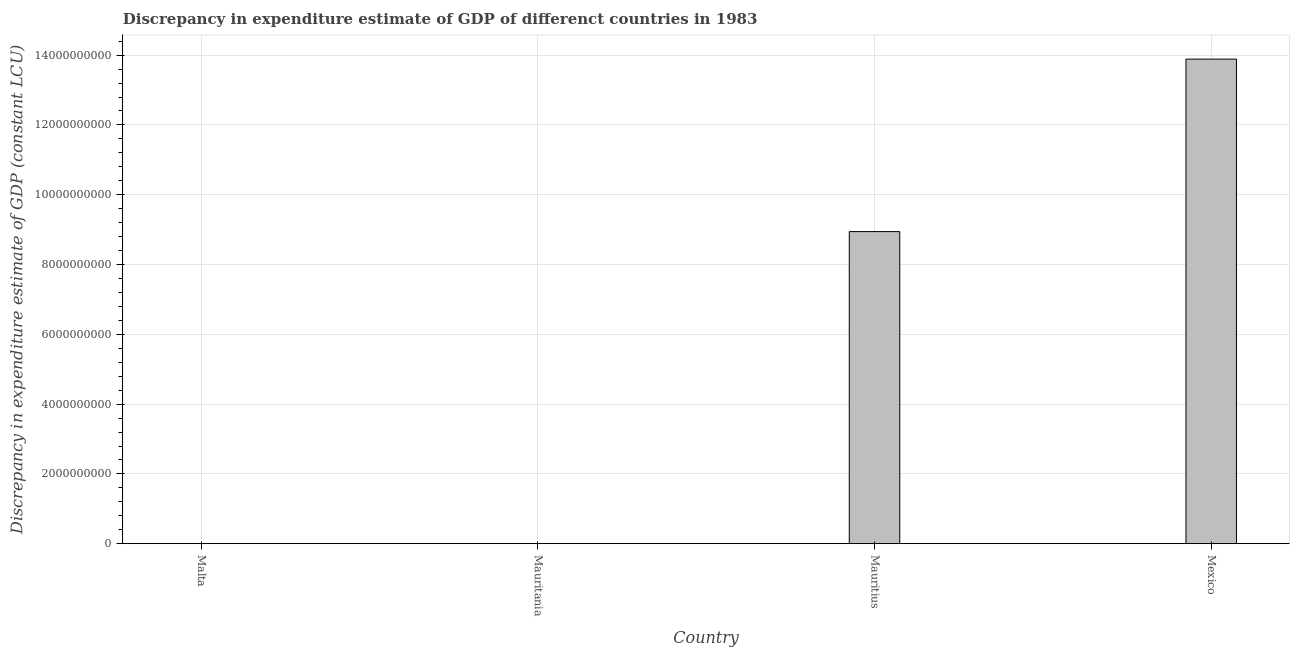Does the graph contain grids?
Provide a short and direct response. Yes. What is the title of the graph?
Give a very brief answer. Discrepancy in expenditure estimate of GDP of differenct countries in 1983. What is the label or title of the X-axis?
Offer a very short reply. Country. What is the label or title of the Y-axis?
Keep it short and to the point. Discrepancy in expenditure estimate of GDP (constant LCU). What is the discrepancy in expenditure estimate of gdp in Mexico?
Your answer should be compact. 1.39e+1. Across all countries, what is the maximum discrepancy in expenditure estimate of gdp?
Your answer should be very brief. 1.39e+1. Across all countries, what is the minimum discrepancy in expenditure estimate of gdp?
Offer a very short reply. 0. What is the sum of the discrepancy in expenditure estimate of gdp?
Provide a succinct answer. 2.28e+1. What is the average discrepancy in expenditure estimate of gdp per country?
Provide a short and direct response. 5.71e+09. What is the median discrepancy in expenditure estimate of gdp?
Provide a short and direct response. 4.47e+09. In how many countries, is the discrepancy in expenditure estimate of gdp greater than 1200000000 LCU?
Offer a very short reply. 2. What is the ratio of the discrepancy in expenditure estimate of gdp in Mauritius to that in Mexico?
Offer a terse response. 0.64. What is the difference between the highest and the lowest discrepancy in expenditure estimate of gdp?
Offer a terse response. 1.39e+1. In how many countries, is the discrepancy in expenditure estimate of gdp greater than the average discrepancy in expenditure estimate of gdp taken over all countries?
Offer a very short reply. 2. How many bars are there?
Keep it short and to the point. 2. Are all the bars in the graph horizontal?
Provide a succinct answer. No. Are the values on the major ticks of Y-axis written in scientific E-notation?
Your response must be concise. No. What is the Discrepancy in expenditure estimate of GDP (constant LCU) of Malta?
Offer a terse response. 0. What is the Discrepancy in expenditure estimate of GDP (constant LCU) of Mauritius?
Offer a terse response. 8.94e+09. What is the Discrepancy in expenditure estimate of GDP (constant LCU) of Mexico?
Your answer should be compact. 1.39e+1. What is the difference between the Discrepancy in expenditure estimate of GDP (constant LCU) in Mauritius and Mexico?
Your response must be concise. -4.94e+09. What is the ratio of the Discrepancy in expenditure estimate of GDP (constant LCU) in Mauritius to that in Mexico?
Give a very brief answer. 0.64. 